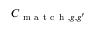<formula> <loc_0><loc_0><loc_500><loc_500>C _ { m a t c h , g , g ^ { \prime } }</formula> 